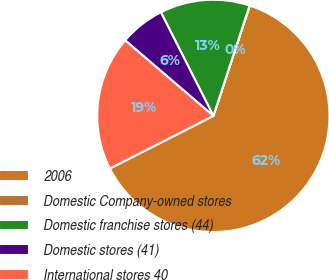<chart> <loc_0><loc_0><loc_500><loc_500><pie_chart><fcel>2006<fcel>Domestic Company-owned stores<fcel>Domestic franchise stores (44)<fcel>Domestic stores (41)<fcel>International stores 40<nl><fcel>62.43%<fcel>0.03%<fcel>12.51%<fcel>6.27%<fcel>18.75%<nl></chart> 